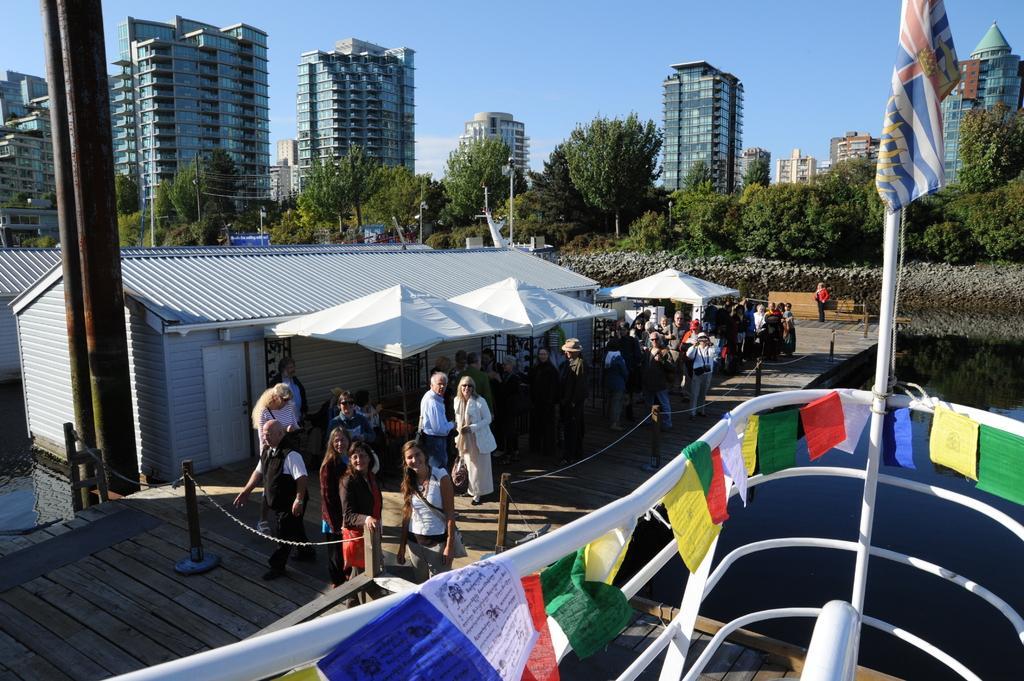How would you summarize this image in a sentence or two? In this image there is a path, on that path there are people, tents, houses, in the background there are trees, buildings and a sky, on the right side there is a ship on the water. 